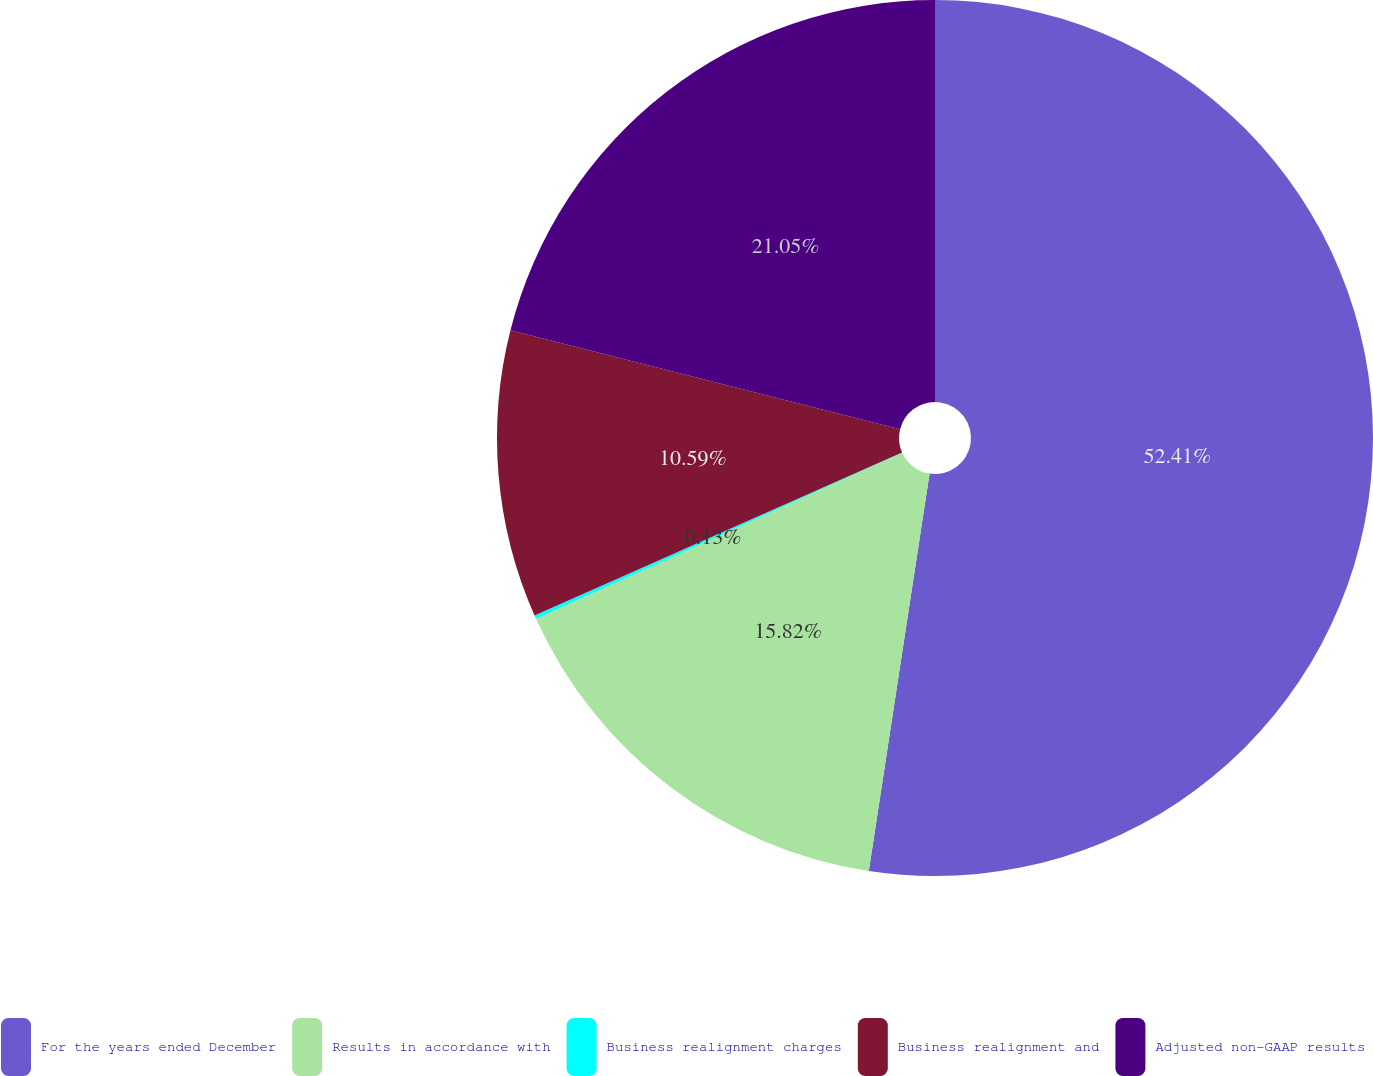Convert chart. <chart><loc_0><loc_0><loc_500><loc_500><pie_chart><fcel>For the years ended December<fcel>Results in accordance with<fcel>Business realignment charges<fcel>Business realignment and<fcel>Adjusted non-GAAP results<nl><fcel>52.42%<fcel>15.82%<fcel>0.13%<fcel>10.59%<fcel>21.05%<nl></chart> 